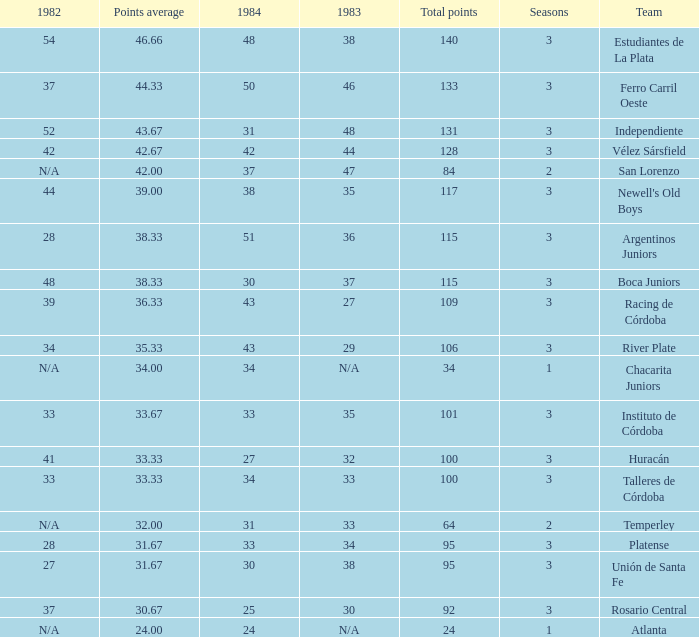What is the total for 1984 for the team with 100 points total and more than 3 seasons? None. Parse the table in full. {'header': ['1982', 'Points average', '1984', '1983', 'Total points', 'Seasons', 'Team'], 'rows': [['54', '46.66', '48', '38', '140', '3', 'Estudiantes de La Plata'], ['37', '44.33', '50', '46', '133', '3', 'Ferro Carril Oeste'], ['52', '43.67', '31', '48', '131', '3', 'Independiente'], ['42', '42.67', '42', '44', '128', '3', 'Vélez Sársfield'], ['N/A', '42.00', '37', '47', '84', '2', 'San Lorenzo'], ['44', '39.00', '38', '35', '117', '3', "Newell's Old Boys"], ['28', '38.33', '51', '36', '115', '3', 'Argentinos Juniors'], ['48', '38.33', '30', '37', '115', '3', 'Boca Juniors'], ['39', '36.33', '43', '27', '109', '3', 'Racing de Córdoba'], ['34', '35.33', '43', '29', '106', '3', 'River Plate'], ['N/A', '34.00', '34', 'N/A', '34', '1', 'Chacarita Juniors'], ['33', '33.67', '33', '35', '101', '3', 'Instituto de Córdoba'], ['41', '33.33', '27', '32', '100', '3', 'Huracán'], ['33', '33.33', '34', '33', '100', '3', 'Talleres de Córdoba'], ['N/A', '32.00', '31', '33', '64', '2', 'Temperley'], ['28', '31.67', '33', '34', '95', '3', 'Platense'], ['27', '31.67', '30', '38', '95', '3', 'Unión de Santa Fe'], ['37', '30.67', '25', '30', '92', '3', 'Rosario Central'], ['N/A', '24.00', '24', 'N/A', '24', '1', 'Atlanta']]} 